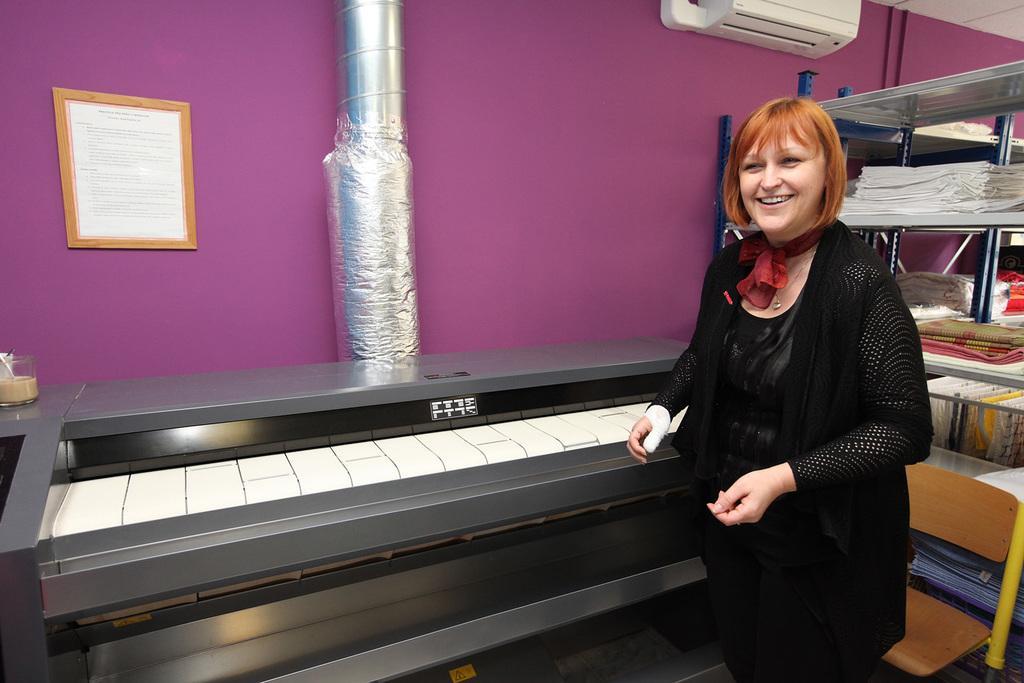Can you describe this image briefly? In this image, we can see a woman standing and there is an object looks like a piano, we can see the steel pipe, we can see the AC, there is a rack and there are some objects in the rack, we can see the wall and there is a photo on the wall. 